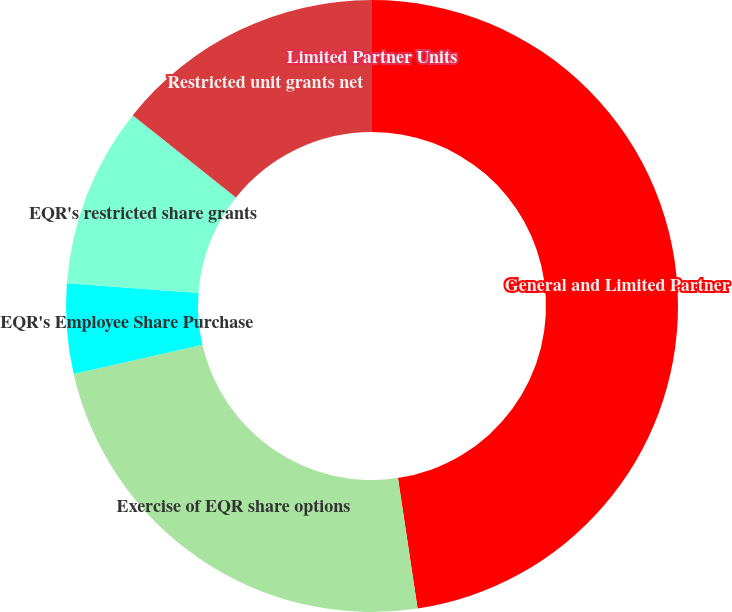Convert chart to OTSL. <chart><loc_0><loc_0><loc_500><loc_500><pie_chart><fcel>General and Limited Partner<fcel>Exercise of EQR share options<fcel>EQR's Employee Share Purchase<fcel>EQR's restricted share grants<fcel>Restricted unit grants net<fcel>Limited Partner Units<nl><fcel>47.62%<fcel>23.81%<fcel>4.76%<fcel>9.52%<fcel>14.29%<fcel>0.0%<nl></chart> 